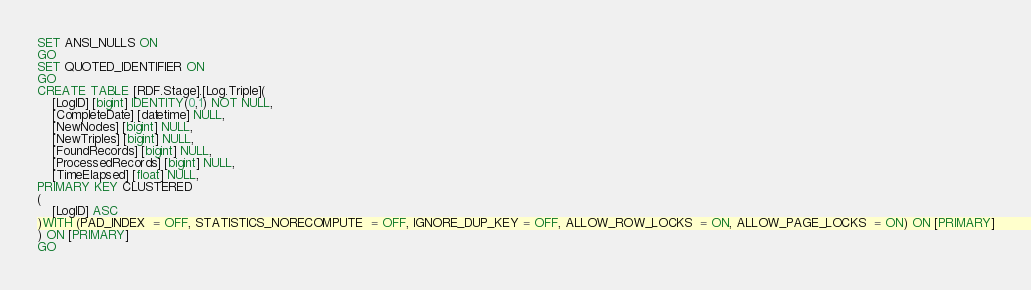<code> <loc_0><loc_0><loc_500><loc_500><_SQL_>SET ANSI_NULLS ON
GO
SET QUOTED_IDENTIFIER ON
GO
CREATE TABLE [RDF.Stage].[Log.Triple](
	[LogID] [bigint] IDENTITY(0,1) NOT NULL,
	[CompleteDate] [datetime] NULL,
	[NewNodes] [bigint] NULL,
	[NewTriples] [bigint] NULL,
	[FoundRecords] [bigint] NULL,
	[ProcessedRecords] [bigint] NULL,
	[TimeElapsed] [float] NULL,
PRIMARY KEY CLUSTERED 
(
	[LogID] ASC
)WITH (PAD_INDEX  = OFF, STATISTICS_NORECOMPUTE  = OFF, IGNORE_DUP_KEY = OFF, ALLOW_ROW_LOCKS  = ON, ALLOW_PAGE_LOCKS  = ON) ON [PRIMARY]
) ON [PRIMARY]
GO
</code> 